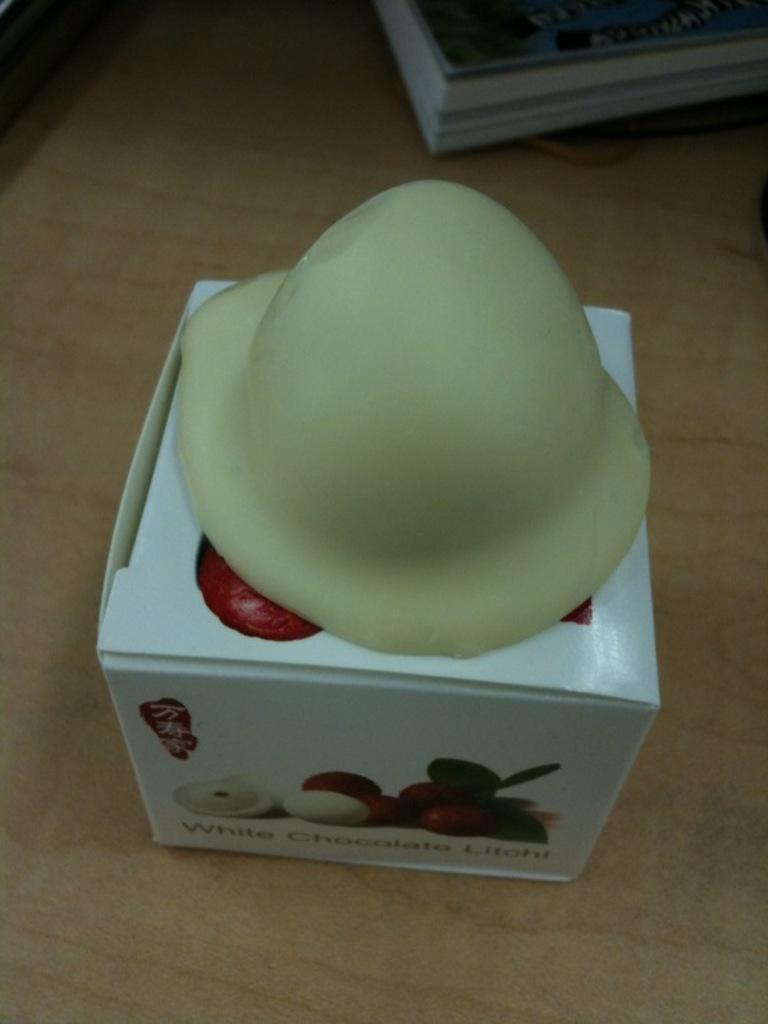In one or two sentences, can you explain what this image depicts? Here I can see a white color box is placed on the floor. On this box there is a white color chocolate. On the top of the image there is a book. 